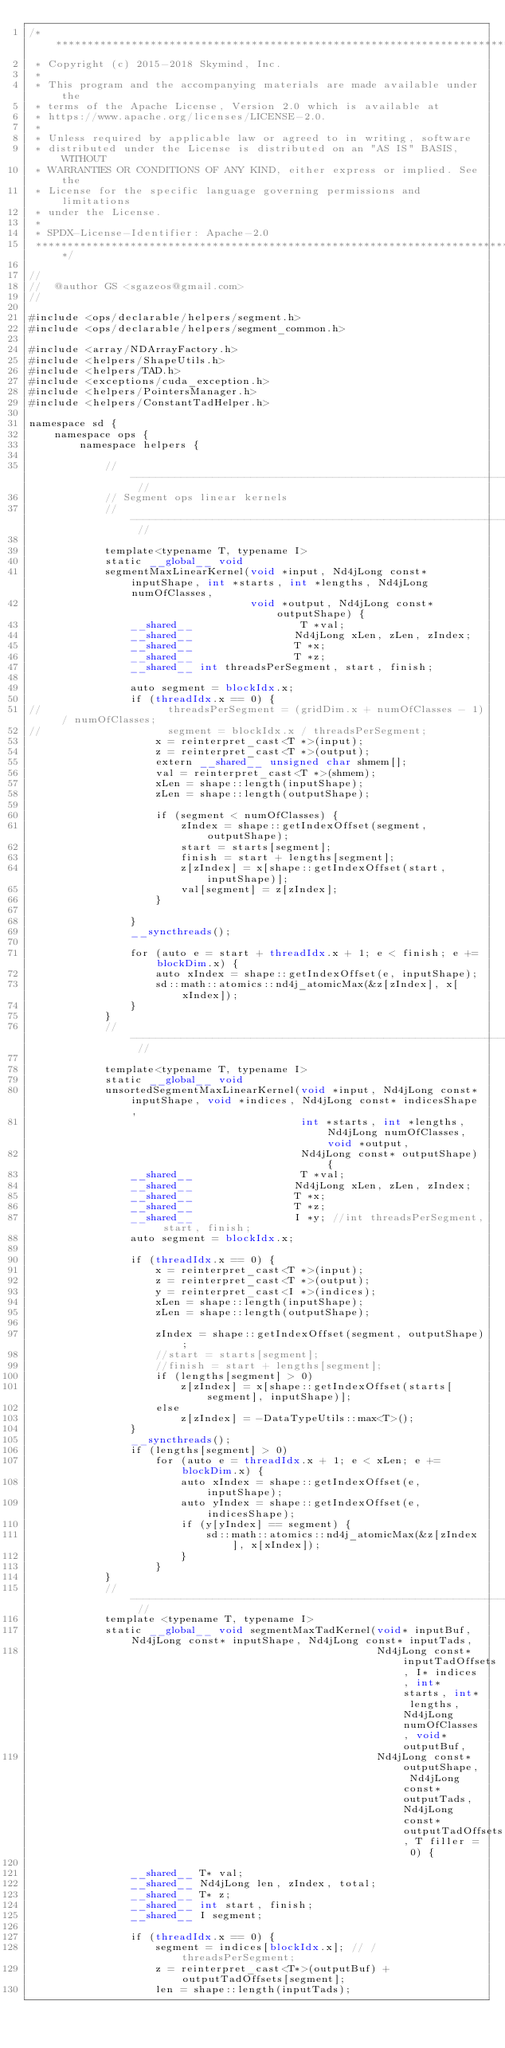<code> <loc_0><loc_0><loc_500><loc_500><_Cuda_>/*******************************************************************************
 * Copyright (c) 2015-2018 Skymind, Inc.
 *
 * This program and the accompanying materials are made available under the
 * terms of the Apache License, Version 2.0 which is available at
 * https://www.apache.org/licenses/LICENSE-2.0.
 *
 * Unless required by applicable law or agreed to in writing, software
 * distributed under the License is distributed on an "AS IS" BASIS, WITHOUT
 * WARRANTIES OR CONDITIONS OF ANY KIND, either express or implied. See the
 * License for the specific language governing permissions and limitations
 * under the License.
 *
 * SPDX-License-Identifier: Apache-2.0
 ******************************************************************************/

//
//  @author GS <sgazeos@gmail.com>
//

#include <ops/declarable/helpers/segment.h>
#include <ops/declarable/helpers/segment_common.h>

#include <array/NDArrayFactory.h>
#include <helpers/ShapeUtils.h>
#include <helpers/TAD.h>
#include <exceptions/cuda_exception.h>
#include <helpers/PointersManager.h>
#include <helpers/ConstantTadHelper.h>

namespace sd {
    namespace ops {
        namespace helpers {

            // -------------------------------------------------------------------------------------------------------------- //
            // Segment ops linear kernels
            // -------------------------------------------------------------------------------------------------------------- //

            template<typename T, typename I>
            static __global__ void
            segmentMaxLinearKernel(void *input, Nd4jLong const* inputShape, int *starts, int *lengths, Nd4jLong numOfClasses,
                                   void *output, Nd4jLong const* outputShape) {
                __shared__                 T *val;
                __shared__                Nd4jLong xLen, zLen, zIndex;
                __shared__                T *x;
                __shared__                T *z;
                __shared__ int threadsPerSegment, start, finish;

                auto segment = blockIdx.x;
                if (threadIdx.x == 0) {
//                    threadsPerSegment = (gridDim.x + numOfClasses - 1) / numOfClasses;
//                    segment = blockIdx.x / threadsPerSegment;
                    x = reinterpret_cast<T *>(input);
                    z = reinterpret_cast<T *>(output);
                    extern __shared__ unsigned char shmem[];
                    val = reinterpret_cast<T *>(shmem);
                    xLen = shape::length(inputShape);
                    zLen = shape::length(outputShape);

                    if (segment < numOfClasses) {
                        zIndex = shape::getIndexOffset(segment, outputShape);
                        start = starts[segment];
                        finish = start + lengths[segment];
                        z[zIndex] = x[shape::getIndexOffset(start, inputShape)];
                        val[segment] = z[zIndex];
                    }

                }
                __syncthreads();

                for (auto e = start + threadIdx.x + 1; e < finish; e += blockDim.x) {
                    auto xIndex = shape::getIndexOffset(e, inputShape);
                    sd::math::atomics::nd4j_atomicMax(&z[zIndex], x[xIndex]);
                }
            }
            // -------------------------------------------------------------------------------------------------------------- //

            template<typename T, typename I>
            static __global__ void
            unsortedSegmentMaxLinearKernel(void *input, Nd4jLong const* inputShape, void *indices, Nd4jLong const* indicesShape,
                                           int *starts, int *lengths, Nd4jLong numOfClasses, void *output,
                                           Nd4jLong const* outputShape) {
                __shared__                 T *val;
                __shared__                Nd4jLong xLen, zLen, zIndex;
                __shared__                T *x;
                __shared__                T *z;
                __shared__                I *y; //int threadsPerSegment, start, finish;
                auto segment = blockIdx.x;

                if (threadIdx.x == 0) {
                    x = reinterpret_cast<T *>(input);
                    z = reinterpret_cast<T *>(output);
                    y = reinterpret_cast<I *>(indices);
                    xLen = shape::length(inputShape);
                    zLen = shape::length(outputShape);

                    zIndex = shape::getIndexOffset(segment, outputShape);
                    //start = starts[segment];
                    //finish = start + lengths[segment];
                    if (lengths[segment] > 0)
                        z[zIndex] = x[shape::getIndexOffset(starts[segment], inputShape)];
                    else
                        z[zIndex] = -DataTypeUtils::max<T>();
                }
                __syncthreads();
                if (lengths[segment] > 0)
                    for (auto e = threadIdx.x + 1; e < xLen; e += blockDim.x) {
                        auto xIndex = shape::getIndexOffset(e, inputShape);
                        auto yIndex = shape::getIndexOffset(e, indicesShape);
                        if (y[yIndex] == segment) {
                            sd::math::atomics::nd4j_atomicMax(&z[zIndex], x[xIndex]);
                        }
                    }
            }
            // -------------------------------------------------------------------------------------------------------------- //
            template <typename T, typename I>
            static __global__ void segmentMaxTadKernel(void* inputBuf, Nd4jLong const* inputShape, Nd4jLong const* inputTads,
                                                       Nd4jLong const* inputTadOffsets, I* indices, int* starts, int* lengths, Nd4jLong numOfClasses, void* outputBuf,
                                                       Nd4jLong const* outputShape, Nd4jLong const* outputTads, Nd4jLong const* outputTadOffsets, T filler = 0) {

                __shared__ T* val;
                __shared__ Nd4jLong len, zIndex, total;
                __shared__ T* z;
                __shared__ int start, finish;
                __shared__ I segment;

                if (threadIdx.x == 0) {
                    segment = indices[blockIdx.x]; // / threadsPerSegment;
                    z = reinterpret_cast<T*>(outputBuf) + outputTadOffsets[segment];
                    len = shape::length(inputTads);
</code> 